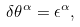Convert formula to latex. <formula><loc_0><loc_0><loc_500><loc_500>\delta \theta ^ { \alpha } = \epsilon ^ { \alpha } ,</formula> 